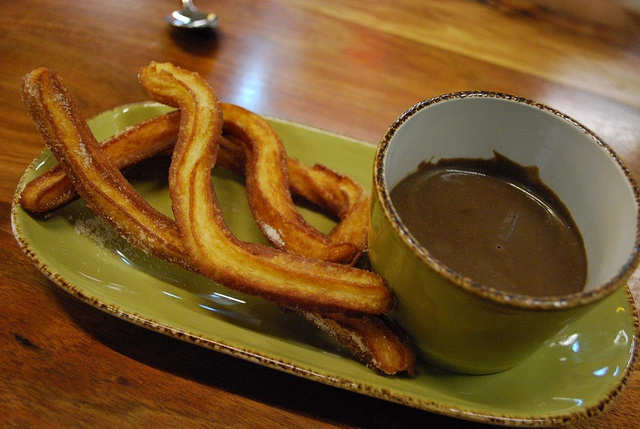Describe the objects in this image and their specific colors. I can see dining table in maroon, brown, gray, and black tones, cup in maroon, gray, black, and olive tones, and spoon in maroon, gray, white, and darkgray tones in this image. 